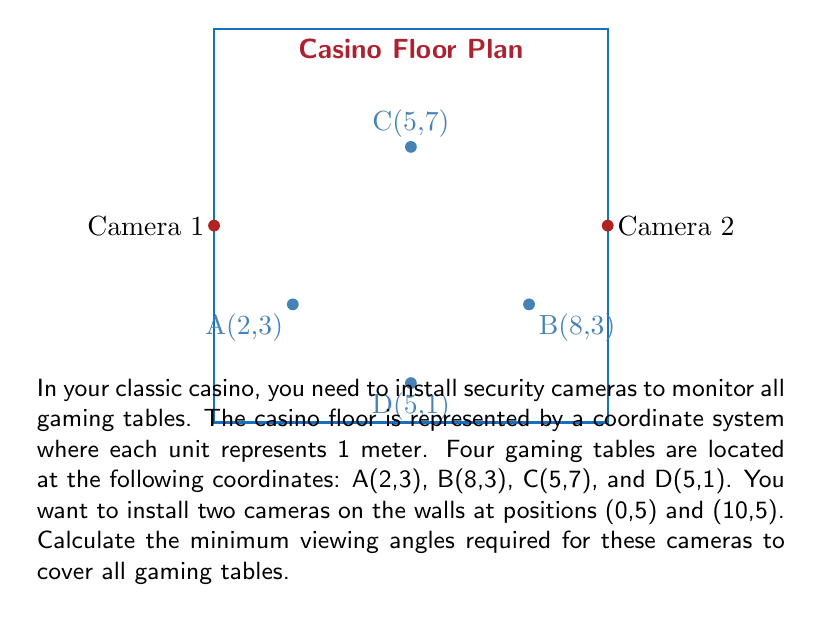Teach me how to tackle this problem. Let's approach this step-by-step:

1) For Camera 1 at (0,5):
   - We need to find the angles to the furthest points above and below the camera's horizontal line.
   - The highest point is C(5,7) and the lowest is D(5,1).
   - For point C: tan θ = (7-5) / 5 = 2/5
   - For point D: tan θ = (5-1) / 5 = 4/5
   - The total angle is: θ₁ = arctan(2/5) + arctan(4/5)

2) For Camera 2 at (10,5):
   - Similarly, we need to find angles to C(5,7) and D(5,1).
   - For point C: tan θ = (7-5) / 5 = 2/5
   - For point D: tan θ = (5-1) / 5 = 4/5
   - The total angle is: θ₂ = arctan(2/5) + arctan(4/5)

3) Calculate the angles:
   θ₁ = θ₂ = arctan(2/5) + arctan(4/5)
   = arctan(0.4) + arctan(0.8)
   ≈ 21.8° + 38.7°
   ≈ 60.5°

4) Round up to the nearest degree for practical purposes.

Therefore, both cameras need a minimum viewing angle of 61° to cover all gaming tables.
Answer: 61° 